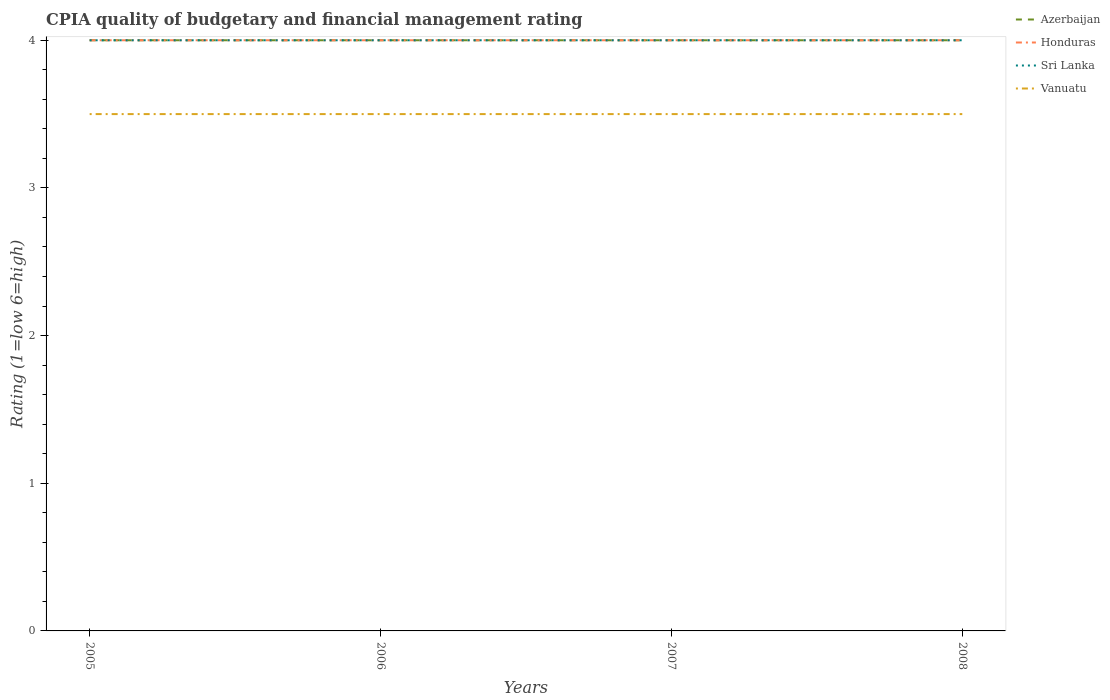How many different coloured lines are there?
Your response must be concise. 4. Does the line corresponding to Azerbaijan intersect with the line corresponding to Sri Lanka?
Provide a succinct answer. Yes. Is the number of lines equal to the number of legend labels?
Your response must be concise. Yes. In which year was the CPIA rating in Sri Lanka maximum?
Provide a succinct answer. 2005. What is the difference between the highest and the second highest CPIA rating in Azerbaijan?
Your response must be concise. 0. What is the difference between the highest and the lowest CPIA rating in Sri Lanka?
Your response must be concise. 0. How many lines are there?
Your response must be concise. 4. Are the values on the major ticks of Y-axis written in scientific E-notation?
Provide a succinct answer. No. Does the graph contain grids?
Give a very brief answer. No. Where does the legend appear in the graph?
Your answer should be compact. Top right. How are the legend labels stacked?
Provide a short and direct response. Vertical. What is the title of the graph?
Make the answer very short. CPIA quality of budgetary and financial management rating. Does "Thailand" appear as one of the legend labels in the graph?
Offer a terse response. No. What is the label or title of the X-axis?
Offer a terse response. Years. What is the label or title of the Y-axis?
Keep it short and to the point. Rating (1=low 6=high). What is the Rating (1=low 6=high) in Azerbaijan in 2005?
Keep it short and to the point. 4. What is the Rating (1=low 6=high) in Honduras in 2005?
Provide a short and direct response. 4. What is the Rating (1=low 6=high) in Vanuatu in 2005?
Your answer should be very brief. 3.5. What is the Rating (1=low 6=high) of Azerbaijan in 2006?
Your answer should be compact. 4. What is the Rating (1=low 6=high) in Honduras in 2006?
Your answer should be compact. 4. What is the Rating (1=low 6=high) of Sri Lanka in 2006?
Ensure brevity in your answer.  4. What is the Rating (1=low 6=high) in Vanuatu in 2006?
Your answer should be very brief. 3.5. What is the Rating (1=low 6=high) in Honduras in 2007?
Give a very brief answer. 4. What is the Rating (1=low 6=high) of Sri Lanka in 2007?
Ensure brevity in your answer.  4. What is the Rating (1=low 6=high) in Azerbaijan in 2008?
Offer a terse response. 4. What is the Rating (1=low 6=high) in Sri Lanka in 2008?
Offer a terse response. 4. Across all years, what is the maximum Rating (1=low 6=high) in Azerbaijan?
Keep it short and to the point. 4. Across all years, what is the maximum Rating (1=low 6=high) in Sri Lanka?
Provide a short and direct response. 4. Across all years, what is the maximum Rating (1=low 6=high) in Vanuatu?
Keep it short and to the point. 3.5. Across all years, what is the minimum Rating (1=low 6=high) in Azerbaijan?
Keep it short and to the point. 4. Across all years, what is the minimum Rating (1=low 6=high) in Honduras?
Make the answer very short. 4. What is the total Rating (1=low 6=high) of Honduras in the graph?
Provide a succinct answer. 16. What is the total Rating (1=low 6=high) of Vanuatu in the graph?
Keep it short and to the point. 14. What is the difference between the Rating (1=low 6=high) of Vanuatu in 2005 and that in 2006?
Offer a terse response. 0. What is the difference between the Rating (1=low 6=high) in Azerbaijan in 2005 and that in 2007?
Offer a very short reply. 0. What is the difference between the Rating (1=low 6=high) in Honduras in 2005 and that in 2007?
Keep it short and to the point. 0. What is the difference between the Rating (1=low 6=high) in Sri Lanka in 2005 and that in 2007?
Offer a very short reply. 0. What is the difference between the Rating (1=low 6=high) of Honduras in 2005 and that in 2008?
Your response must be concise. 0. What is the difference between the Rating (1=low 6=high) in Sri Lanka in 2006 and that in 2007?
Your answer should be very brief. 0. What is the difference between the Rating (1=low 6=high) in Honduras in 2006 and that in 2008?
Offer a terse response. 0. What is the difference between the Rating (1=low 6=high) of Vanuatu in 2006 and that in 2008?
Your answer should be compact. 0. What is the difference between the Rating (1=low 6=high) in Sri Lanka in 2007 and that in 2008?
Keep it short and to the point. 0. What is the difference between the Rating (1=low 6=high) in Azerbaijan in 2005 and the Rating (1=low 6=high) in Honduras in 2006?
Give a very brief answer. 0. What is the difference between the Rating (1=low 6=high) in Azerbaijan in 2005 and the Rating (1=low 6=high) in Sri Lanka in 2006?
Ensure brevity in your answer.  0. What is the difference between the Rating (1=low 6=high) of Honduras in 2005 and the Rating (1=low 6=high) of Sri Lanka in 2006?
Make the answer very short. 0. What is the difference between the Rating (1=low 6=high) in Sri Lanka in 2005 and the Rating (1=low 6=high) in Vanuatu in 2006?
Provide a short and direct response. 0.5. What is the difference between the Rating (1=low 6=high) in Azerbaijan in 2005 and the Rating (1=low 6=high) in Honduras in 2007?
Your response must be concise. 0. What is the difference between the Rating (1=low 6=high) in Azerbaijan in 2005 and the Rating (1=low 6=high) in Vanuatu in 2007?
Your answer should be very brief. 0.5. What is the difference between the Rating (1=low 6=high) in Honduras in 2005 and the Rating (1=low 6=high) in Vanuatu in 2007?
Your answer should be very brief. 0.5. What is the difference between the Rating (1=low 6=high) of Azerbaijan in 2005 and the Rating (1=low 6=high) of Honduras in 2008?
Provide a short and direct response. 0. What is the difference between the Rating (1=low 6=high) in Azerbaijan in 2005 and the Rating (1=low 6=high) in Sri Lanka in 2008?
Keep it short and to the point. 0. What is the difference between the Rating (1=low 6=high) of Honduras in 2005 and the Rating (1=low 6=high) of Sri Lanka in 2008?
Make the answer very short. 0. What is the difference between the Rating (1=low 6=high) of Sri Lanka in 2005 and the Rating (1=low 6=high) of Vanuatu in 2008?
Your answer should be very brief. 0.5. What is the difference between the Rating (1=low 6=high) in Azerbaijan in 2006 and the Rating (1=low 6=high) in Honduras in 2007?
Your response must be concise. 0. What is the difference between the Rating (1=low 6=high) of Honduras in 2006 and the Rating (1=low 6=high) of Sri Lanka in 2007?
Ensure brevity in your answer.  0. What is the difference between the Rating (1=low 6=high) in Honduras in 2006 and the Rating (1=low 6=high) in Vanuatu in 2007?
Keep it short and to the point. 0.5. What is the difference between the Rating (1=low 6=high) in Sri Lanka in 2006 and the Rating (1=low 6=high) in Vanuatu in 2007?
Ensure brevity in your answer.  0.5. What is the difference between the Rating (1=low 6=high) in Azerbaijan in 2006 and the Rating (1=low 6=high) in Honduras in 2008?
Provide a succinct answer. 0. What is the difference between the Rating (1=low 6=high) in Azerbaijan in 2006 and the Rating (1=low 6=high) in Sri Lanka in 2008?
Your answer should be compact. 0. What is the difference between the Rating (1=low 6=high) of Honduras in 2006 and the Rating (1=low 6=high) of Sri Lanka in 2008?
Your response must be concise. 0. What is the difference between the Rating (1=low 6=high) in Sri Lanka in 2006 and the Rating (1=low 6=high) in Vanuatu in 2008?
Make the answer very short. 0.5. What is the difference between the Rating (1=low 6=high) in Azerbaijan in 2007 and the Rating (1=low 6=high) in Honduras in 2008?
Your answer should be compact. 0. What is the difference between the Rating (1=low 6=high) in Azerbaijan in 2007 and the Rating (1=low 6=high) in Sri Lanka in 2008?
Your answer should be very brief. 0. What is the average Rating (1=low 6=high) of Azerbaijan per year?
Keep it short and to the point. 4. What is the average Rating (1=low 6=high) of Honduras per year?
Provide a short and direct response. 4. What is the average Rating (1=low 6=high) of Vanuatu per year?
Keep it short and to the point. 3.5. In the year 2005, what is the difference between the Rating (1=low 6=high) of Azerbaijan and Rating (1=low 6=high) of Sri Lanka?
Your answer should be very brief. 0. In the year 2005, what is the difference between the Rating (1=low 6=high) of Honduras and Rating (1=low 6=high) of Sri Lanka?
Give a very brief answer. 0. In the year 2005, what is the difference between the Rating (1=low 6=high) of Sri Lanka and Rating (1=low 6=high) of Vanuatu?
Your response must be concise. 0.5. In the year 2006, what is the difference between the Rating (1=low 6=high) in Azerbaijan and Rating (1=low 6=high) in Honduras?
Your answer should be very brief. 0. In the year 2006, what is the difference between the Rating (1=low 6=high) in Azerbaijan and Rating (1=low 6=high) in Vanuatu?
Ensure brevity in your answer.  0.5. In the year 2006, what is the difference between the Rating (1=low 6=high) in Honduras and Rating (1=low 6=high) in Sri Lanka?
Your answer should be compact. 0. In the year 2006, what is the difference between the Rating (1=low 6=high) of Honduras and Rating (1=low 6=high) of Vanuatu?
Provide a succinct answer. 0.5. In the year 2007, what is the difference between the Rating (1=low 6=high) of Azerbaijan and Rating (1=low 6=high) of Honduras?
Offer a terse response. 0. In the year 2007, what is the difference between the Rating (1=low 6=high) of Azerbaijan and Rating (1=low 6=high) of Vanuatu?
Your answer should be compact. 0.5. In the year 2007, what is the difference between the Rating (1=low 6=high) of Honduras and Rating (1=low 6=high) of Sri Lanka?
Offer a terse response. 0. In the year 2008, what is the difference between the Rating (1=low 6=high) in Azerbaijan and Rating (1=low 6=high) in Sri Lanka?
Keep it short and to the point. 0. In the year 2008, what is the difference between the Rating (1=low 6=high) of Azerbaijan and Rating (1=low 6=high) of Vanuatu?
Provide a short and direct response. 0.5. In the year 2008, what is the difference between the Rating (1=low 6=high) of Honduras and Rating (1=low 6=high) of Sri Lanka?
Give a very brief answer. 0. In the year 2008, what is the difference between the Rating (1=low 6=high) in Sri Lanka and Rating (1=low 6=high) in Vanuatu?
Your response must be concise. 0.5. What is the ratio of the Rating (1=low 6=high) of Azerbaijan in 2005 to that in 2006?
Keep it short and to the point. 1. What is the ratio of the Rating (1=low 6=high) of Honduras in 2005 to that in 2006?
Your response must be concise. 1. What is the ratio of the Rating (1=low 6=high) in Sri Lanka in 2005 to that in 2006?
Provide a short and direct response. 1. What is the ratio of the Rating (1=low 6=high) in Vanuatu in 2005 to that in 2006?
Provide a succinct answer. 1. What is the ratio of the Rating (1=low 6=high) of Azerbaijan in 2005 to that in 2007?
Your answer should be very brief. 1. What is the ratio of the Rating (1=low 6=high) of Honduras in 2005 to that in 2007?
Offer a terse response. 1. What is the ratio of the Rating (1=low 6=high) in Sri Lanka in 2005 to that in 2007?
Your answer should be very brief. 1. What is the ratio of the Rating (1=low 6=high) in Azerbaijan in 2005 to that in 2008?
Give a very brief answer. 1. What is the ratio of the Rating (1=low 6=high) of Sri Lanka in 2005 to that in 2008?
Offer a terse response. 1. What is the ratio of the Rating (1=low 6=high) of Vanuatu in 2005 to that in 2008?
Provide a short and direct response. 1. What is the ratio of the Rating (1=low 6=high) of Honduras in 2006 to that in 2007?
Provide a succinct answer. 1. What is the ratio of the Rating (1=low 6=high) in Sri Lanka in 2006 to that in 2007?
Provide a short and direct response. 1. What is the ratio of the Rating (1=low 6=high) in Honduras in 2006 to that in 2008?
Ensure brevity in your answer.  1. What is the ratio of the Rating (1=low 6=high) in Azerbaijan in 2007 to that in 2008?
Keep it short and to the point. 1. What is the ratio of the Rating (1=low 6=high) in Vanuatu in 2007 to that in 2008?
Give a very brief answer. 1. What is the difference between the highest and the second highest Rating (1=low 6=high) in Honduras?
Offer a very short reply. 0. What is the difference between the highest and the lowest Rating (1=low 6=high) of Azerbaijan?
Provide a succinct answer. 0. What is the difference between the highest and the lowest Rating (1=low 6=high) in Vanuatu?
Provide a succinct answer. 0. 